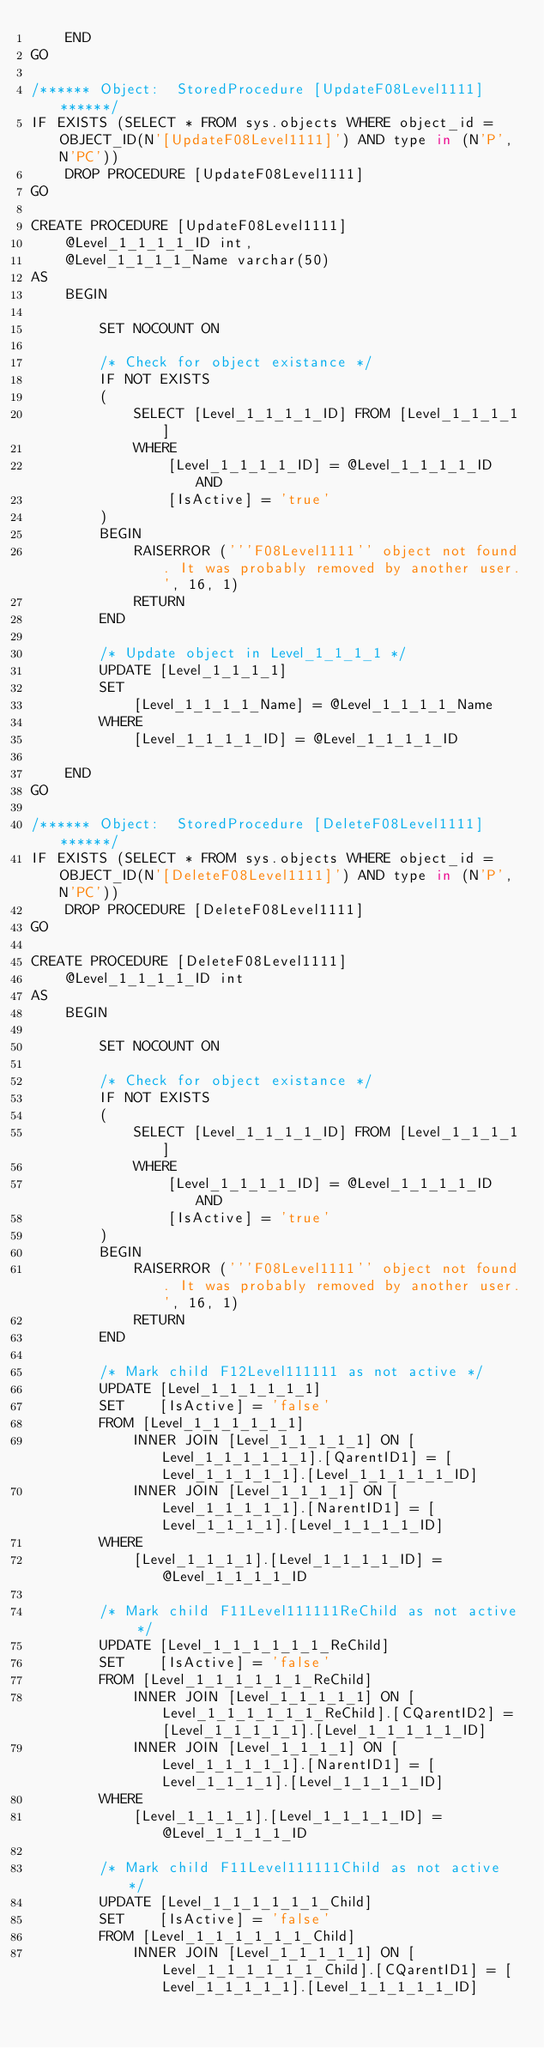<code> <loc_0><loc_0><loc_500><loc_500><_SQL_>    END
GO

/****** Object:  StoredProcedure [UpdateF08Level1111] ******/
IF EXISTS (SELECT * FROM sys.objects WHERE object_id = OBJECT_ID(N'[UpdateF08Level1111]') AND type in (N'P', N'PC'))
    DROP PROCEDURE [UpdateF08Level1111]
GO

CREATE PROCEDURE [UpdateF08Level1111]
    @Level_1_1_1_1_ID int,
    @Level_1_1_1_1_Name varchar(50)
AS
    BEGIN

        SET NOCOUNT ON

        /* Check for object existance */
        IF NOT EXISTS
        (
            SELECT [Level_1_1_1_1_ID] FROM [Level_1_1_1_1]
            WHERE
                [Level_1_1_1_1_ID] = @Level_1_1_1_1_ID AND
                [IsActive] = 'true'
        )
        BEGIN
            RAISERROR ('''F08Level1111'' object not found. It was probably removed by another user.', 16, 1)
            RETURN
        END

        /* Update object in Level_1_1_1_1 */
        UPDATE [Level_1_1_1_1]
        SET
            [Level_1_1_1_1_Name] = @Level_1_1_1_1_Name
        WHERE
            [Level_1_1_1_1_ID] = @Level_1_1_1_1_ID

    END
GO

/****** Object:  StoredProcedure [DeleteF08Level1111] ******/
IF EXISTS (SELECT * FROM sys.objects WHERE object_id = OBJECT_ID(N'[DeleteF08Level1111]') AND type in (N'P', N'PC'))
    DROP PROCEDURE [DeleteF08Level1111]
GO

CREATE PROCEDURE [DeleteF08Level1111]
    @Level_1_1_1_1_ID int
AS
    BEGIN

        SET NOCOUNT ON

        /* Check for object existance */
        IF NOT EXISTS
        (
            SELECT [Level_1_1_1_1_ID] FROM [Level_1_1_1_1]
            WHERE
                [Level_1_1_1_1_ID] = @Level_1_1_1_1_ID AND
                [IsActive] = 'true'
        )
        BEGIN
            RAISERROR ('''F08Level1111'' object not found. It was probably removed by another user.', 16, 1)
            RETURN
        END

        /* Mark child F12Level111111 as not active */
        UPDATE [Level_1_1_1_1_1_1]
        SET    [IsActive] = 'false'
        FROM [Level_1_1_1_1_1_1]
            INNER JOIN [Level_1_1_1_1_1] ON [Level_1_1_1_1_1_1].[QarentID1] = [Level_1_1_1_1_1].[Level_1_1_1_1_1_ID]
            INNER JOIN [Level_1_1_1_1] ON [Level_1_1_1_1_1].[NarentID1] = [Level_1_1_1_1].[Level_1_1_1_1_ID]
        WHERE
            [Level_1_1_1_1].[Level_1_1_1_1_ID] = @Level_1_1_1_1_ID

        /* Mark child F11Level111111ReChild as not active */
        UPDATE [Level_1_1_1_1_1_1_ReChild]
        SET    [IsActive] = 'false'
        FROM [Level_1_1_1_1_1_1_ReChild]
            INNER JOIN [Level_1_1_1_1_1] ON [Level_1_1_1_1_1_1_ReChild].[CQarentID2] = [Level_1_1_1_1_1].[Level_1_1_1_1_1_ID]
            INNER JOIN [Level_1_1_1_1] ON [Level_1_1_1_1_1].[NarentID1] = [Level_1_1_1_1].[Level_1_1_1_1_ID]
        WHERE
            [Level_1_1_1_1].[Level_1_1_1_1_ID] = @Level_1_1_1_1_ID

        /* Mark child F11Level111111Child as not active */
        UPDATE [Level_1_1_1_1_1_1_Child]
        SET    [IsActive] = 'false'
        FROM [Level_1_1_1_1_1_1_Child]
            INNER JOIN [Level_1_1_1_1_1] ON [Level_1_1_1_1_1_1_Child].[CQarentID1] = [Level_1_1_1_1_1].[Level_1_1_1_1_1_ID]</code> 